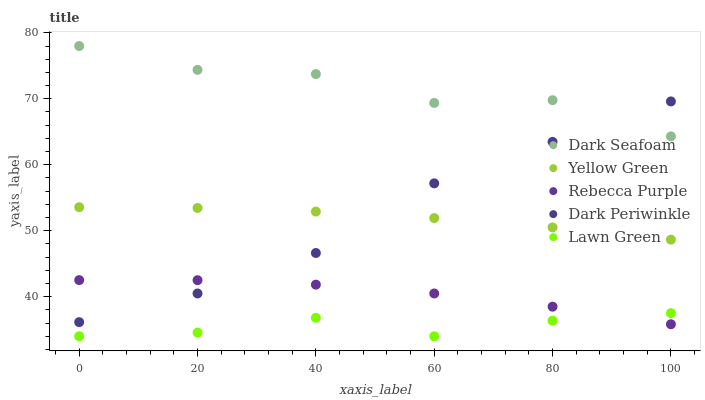Does Lawn Green have the minimum area under the curve?
Answer yes or no. Yes. Does Dark Seafoam have the maximum area under the curve?
Answer yes or no. Yes. Does Dark Seafoam have the minimum area under the curve?
Answer yes or no. No. Does Lawn Green have the maximum area under the curve?
Answer yes or no. No. Is Yellow Green the smoothest?
Answer yes or no. Yes. Is Dark Seafoam the roughest?
Answer yes or no. Yes. Is Lawn Green the smoothest?
Answer yes or no. No. Is Lawn Green the roughest?
Answer yes or no. No. Does Lawn Green have the lowest value?
Answer yes or no. Yes. Does Dark Seafoam have the lowest value?
Answer yes or no. No. Does Dark Seafoam have the highest value?
Answer yes or no. Yes. Does Lawn Green have the highest value?
Answer yes or no. No. Is Lawn Green less than Yellow Green?
Answer yes or no. Yes. Is Dark Seafoam greater than Rebecca Purple?
Answer yes or no. Yes. Does Dark Periwinkle intersect Rebecca Purple?
Answer yes or no. Yes. Is Dark Periwinkle less than Rebecca Purple?
Answer yes or no. No. Is Dark Periwinkle greater than Rebecca Purple?
Answer yes or no. No. Does Lawn Green intersect Yellow Green?
Answer yes or no. No. 